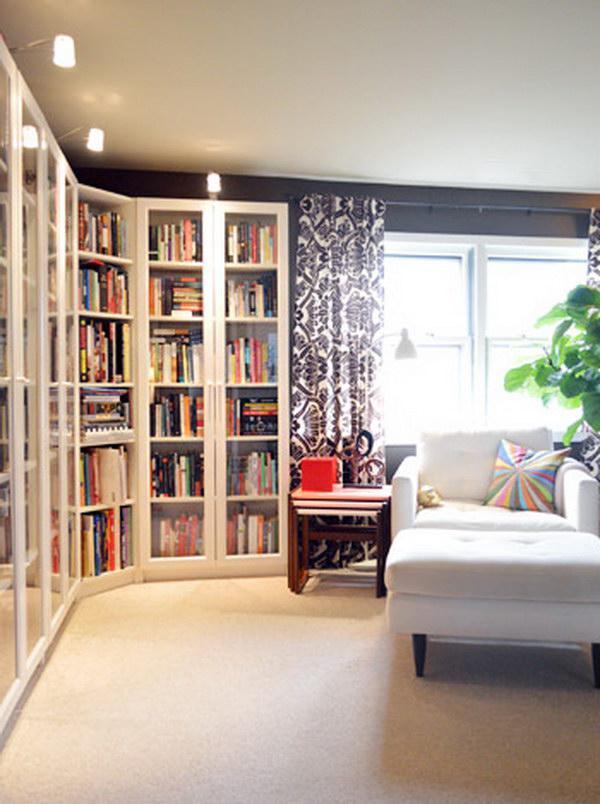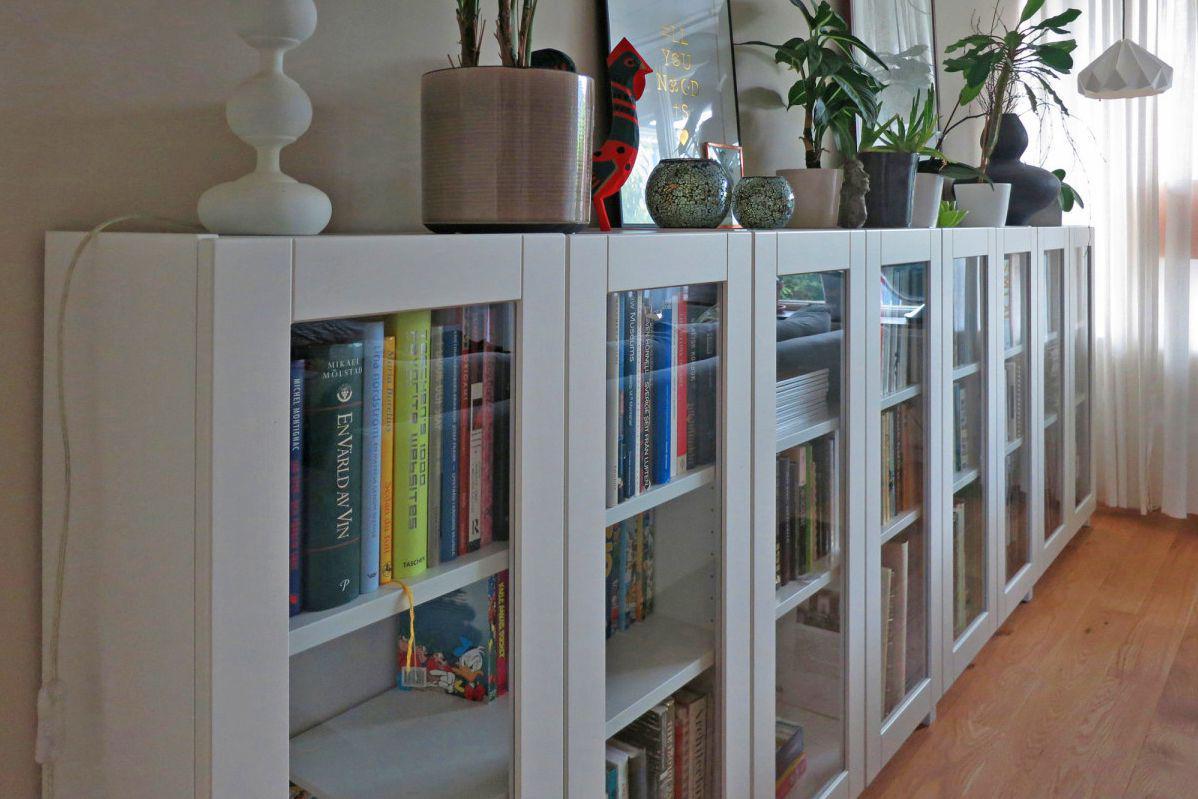The first image is the image on the left, the second image is the image on the right. Examine the images to the left and right. Is the description "The white bookshelves in one image are floor to ceiling and have a sliding ladder with visible track to allow access to upper shelves." accurate? Answer yes or no. No. 